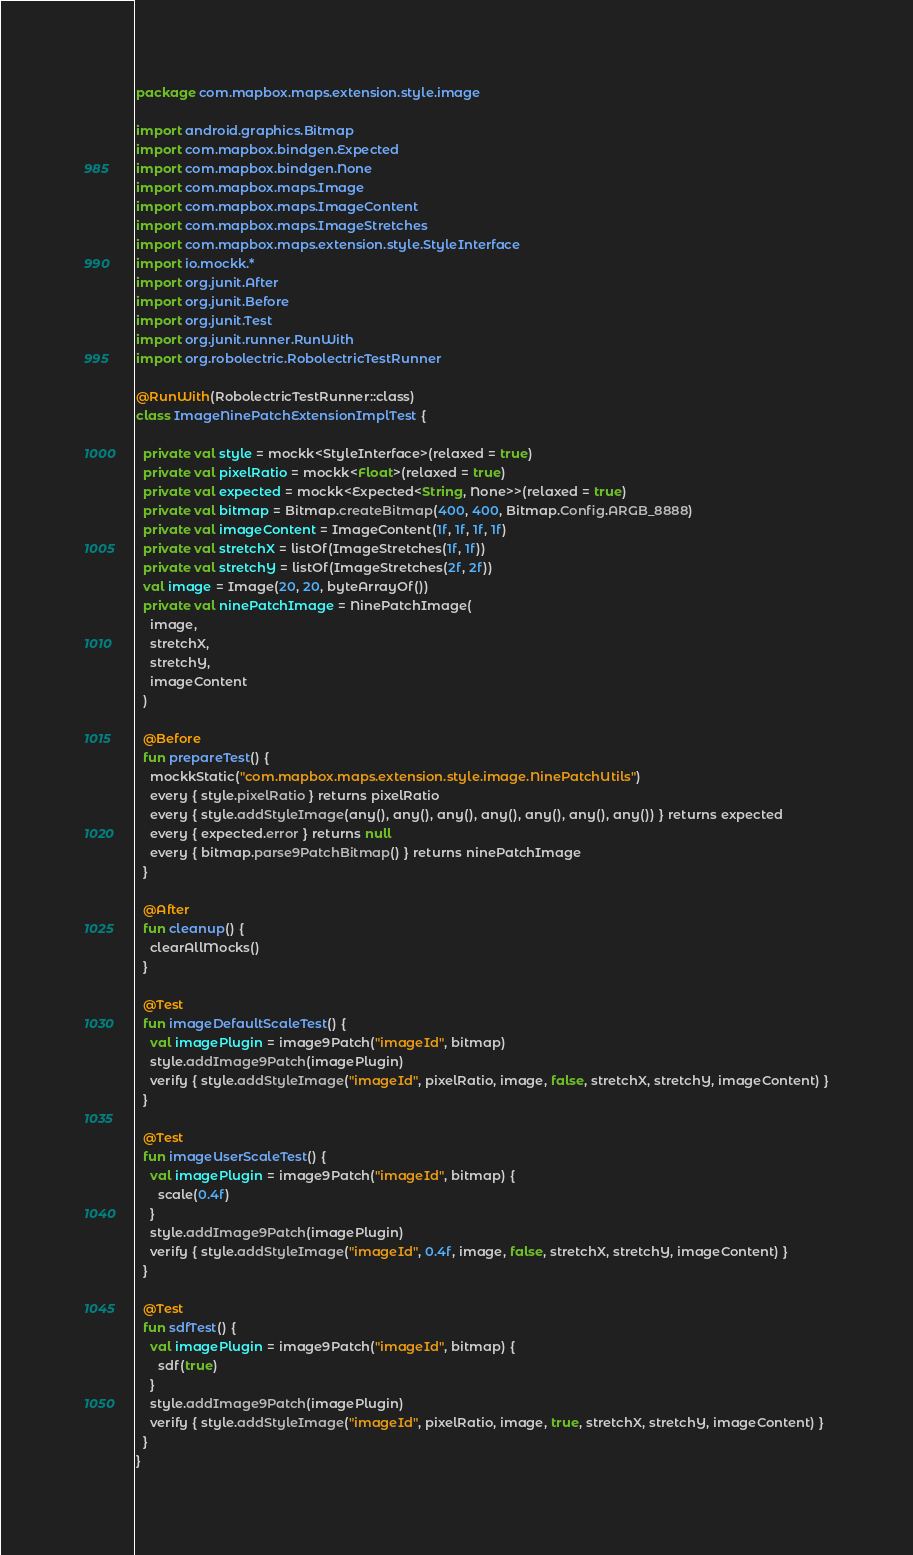<code> <loc_0><loc_0><loc_500><loc_500><_Kotlin_>package com.mapbox.maps.extension.style.image

import android.graphics.Bitmap
import com.mapbox.bindgen.Expected
import com.mapbox.bindgen.None
import com.mapbox.maps.Image
import com.mapbox.maps.ImageContent
import com.mapbox.maps.ImageStretches
import com.mapbox.maps.extension.style.StyleInterface
import io.mockk.*
import org.junit.After
import org.junit.Before
import org.junit.Test
import org.junit.runner.RunWith
import org.robolectric.RobolectricTestRunner

@RunWith(RobolectricTestRunner::class)
class ImageNinePatchExtensionImplTest {

  private val style = mockk<StyleInterface>(relaxed = true)
  private val pixelRatio = mockk<Float>(relaxed = true)
  private val expected = mockk<Expected<String, None>>(relaxed = true)
  private val bitmap = Bitmap.createBitmap(400, 400, Bitmap.Config.ARGB_8888)
  private val imageContent = ImageContent(1f, 1f, 1f, 1f)
  private val stretchX = listOf(ImageStretches(1f, 1f))
  private val stretchY = listOf(ImageStretches(2f, 2f))
  val image = Image(20, 20, byteArrayOf())
  private val ninePatchImage = NinePatchImage(
    image,
    stretchX,
    stretchY,
    imageContent
  )

  @Before
  fun prepareTest() {
    mockkStatic("com.mapbox.maps.extension.style.image.NinePatchUtils")
    every { style.pixelRatio } returns pixelRatio
    every { style.addStyleImage(any(), any(), any(), any(), any(), any(), any()) } returns expected
    every { expected.error } returns null
    every { bitmap.parse9PatchBitmap() } returns ninePatchImage
  }

  @After
  fun cleanup() {
    clearAllMocks()
  }

  @Test
  fun imageDefaultScaleTest() {
    val imagePlugin = image9Patch("imageId", bitmap)
    style.addImage9Patch(imagePlugin)
    verify { style.addStyleImage("imageId", pixelRatio, image, false, stretchX, stretchY, imageContent) }
  }

  @Test
  fun imageUserScaleTest() {
    val imagePlugin = image9Patch("imageId", bitmap) {
      scale(0.4f)
    }
    style.addImage9Patch(imagePlugin)
    verify { style.addStyleImage("imageId", 0.4f, image, false, stretchX, stretchY, imageContent) }
  }

  @Test
  fun sdfTest() {
    val imagePlugin = image9Patch("imageId", bitmap) {
      sdf(true)
    }
    style.addImage9Patch(imagePlugin)
    verify { style.addStyleImage("imageId", pixelRatio, image, true, stretchX, stretchY, imageContent) }
  }
}</code> 